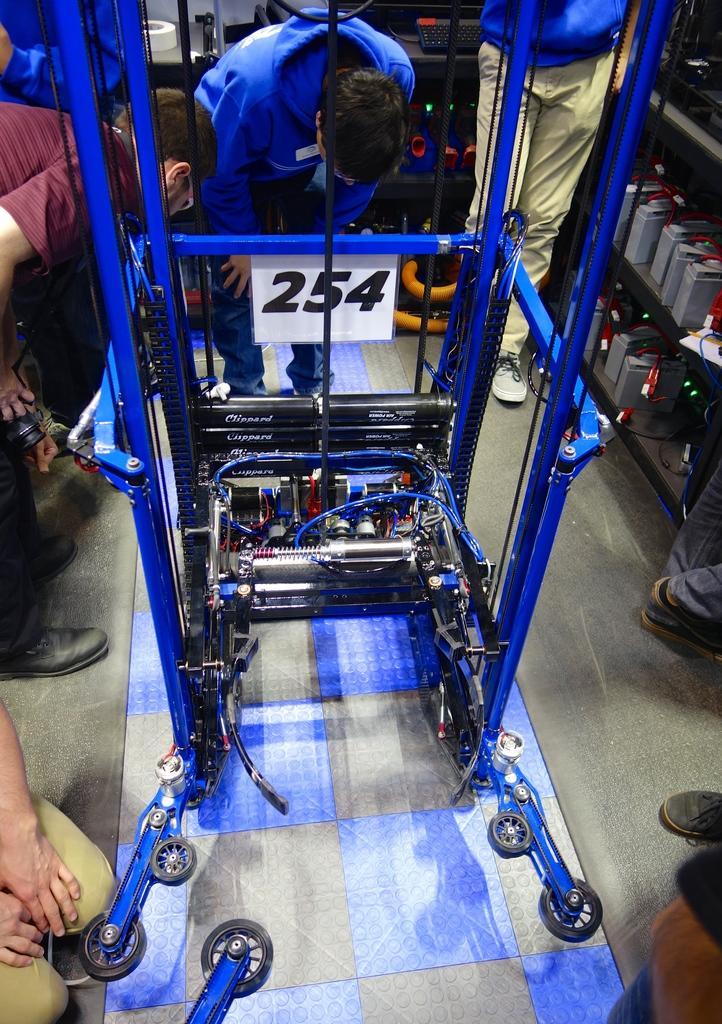Can you describe this image briefly? In this image we can see a machine which has wheels and a number board is in blue color. Here we can see these people are standing around the machine. In the background, we can see batteries on the shelf and a keyboard here. 